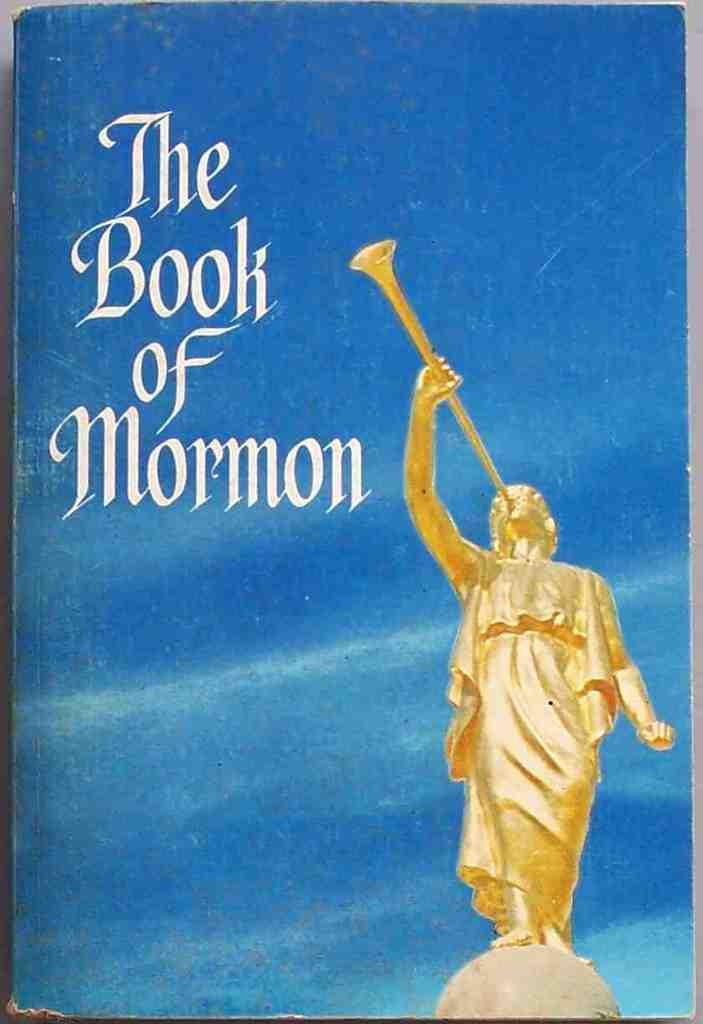<image>
Offer a succinct explanation of the picture presented. a book with a blue cover titled 'the book of mormon' 